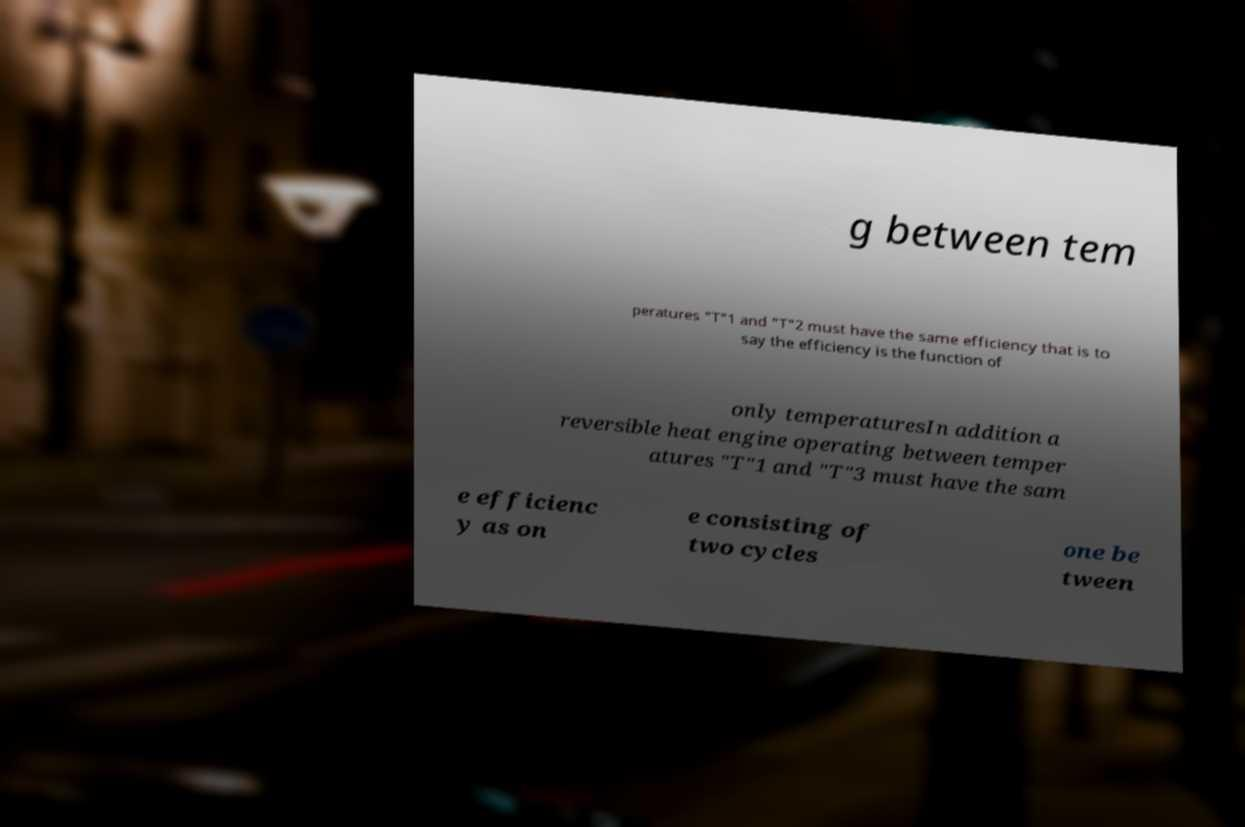Can you accurately transcribe the text from the provided image for me? g between tem peratures "T"1 and "T"2 must have the same efficiency that is to say the efficiency is the function of only temperaturesIn addition a reversible heat engine operating between temper atures "T"1 and "T"3 must have the sam e efficienc y as on e consisting of two cycles one be tween 